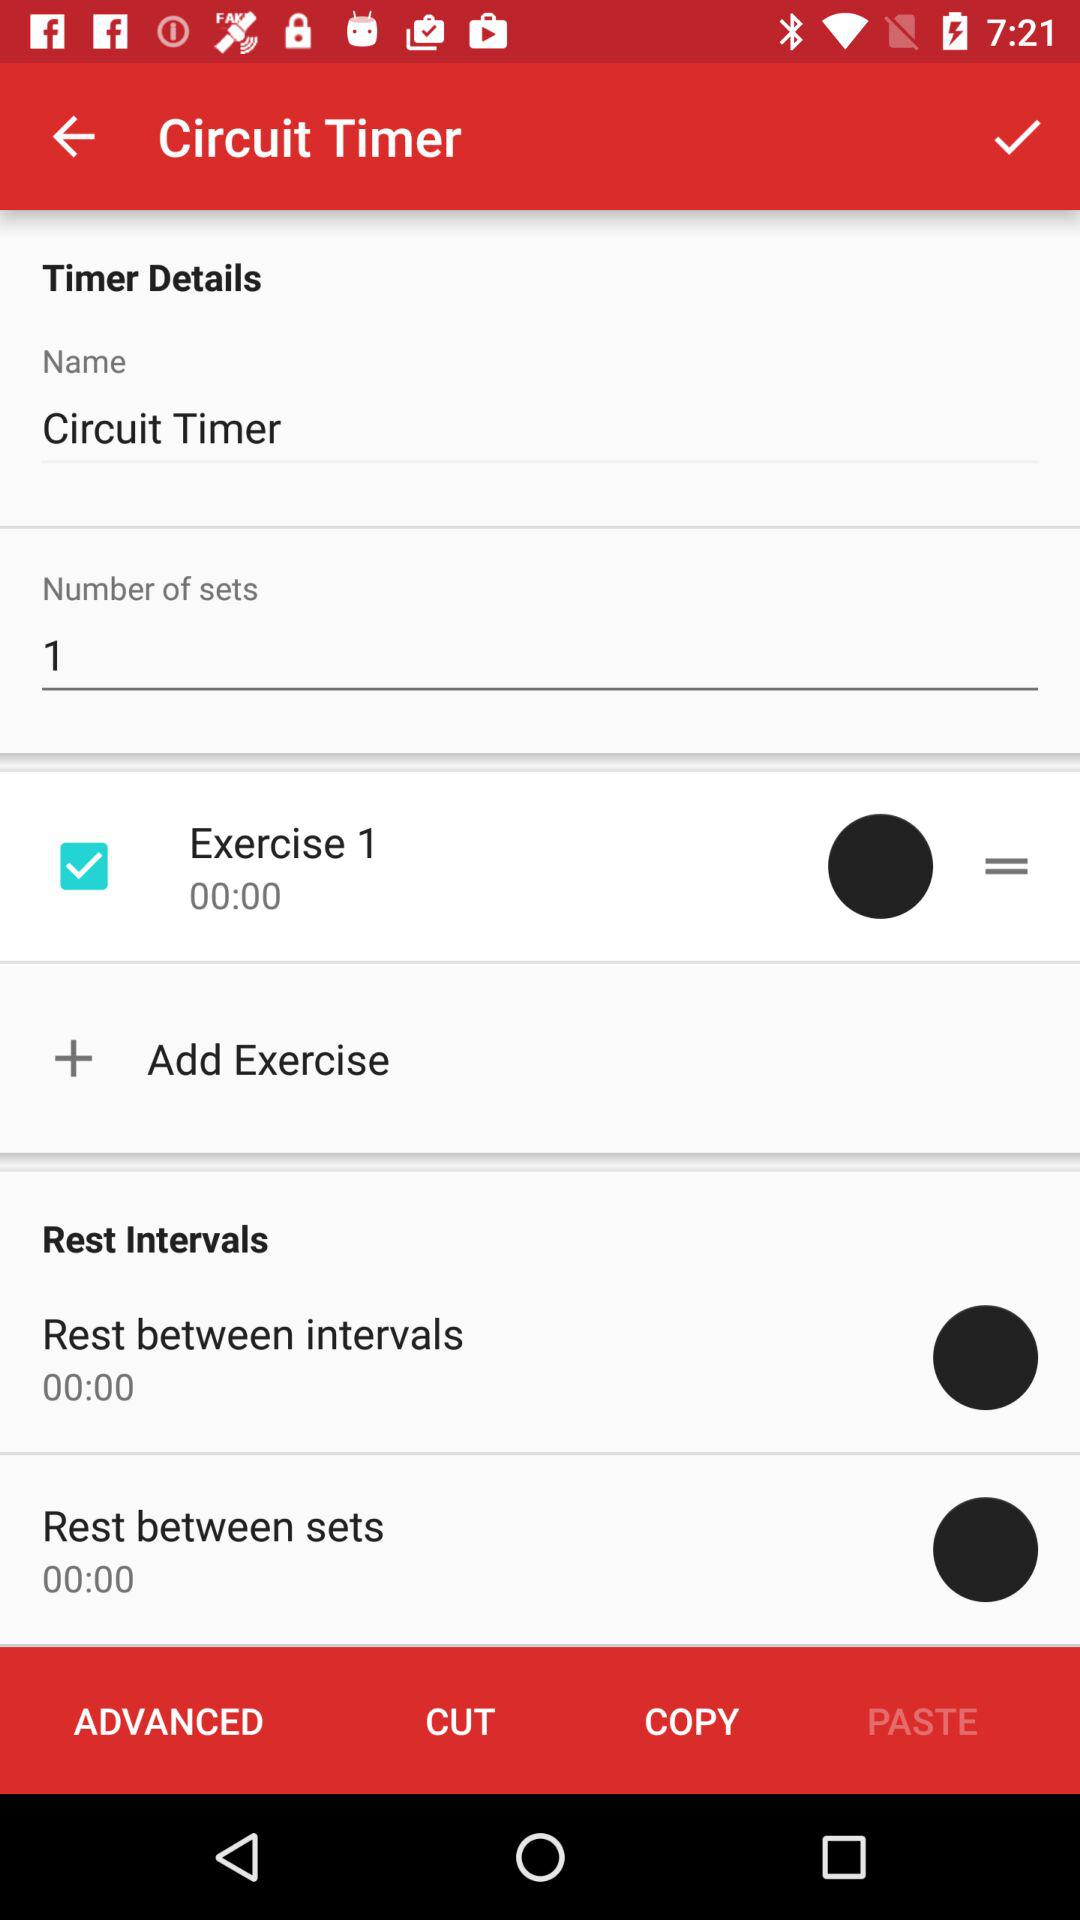What is the number of sets? The number of sets is 1. 